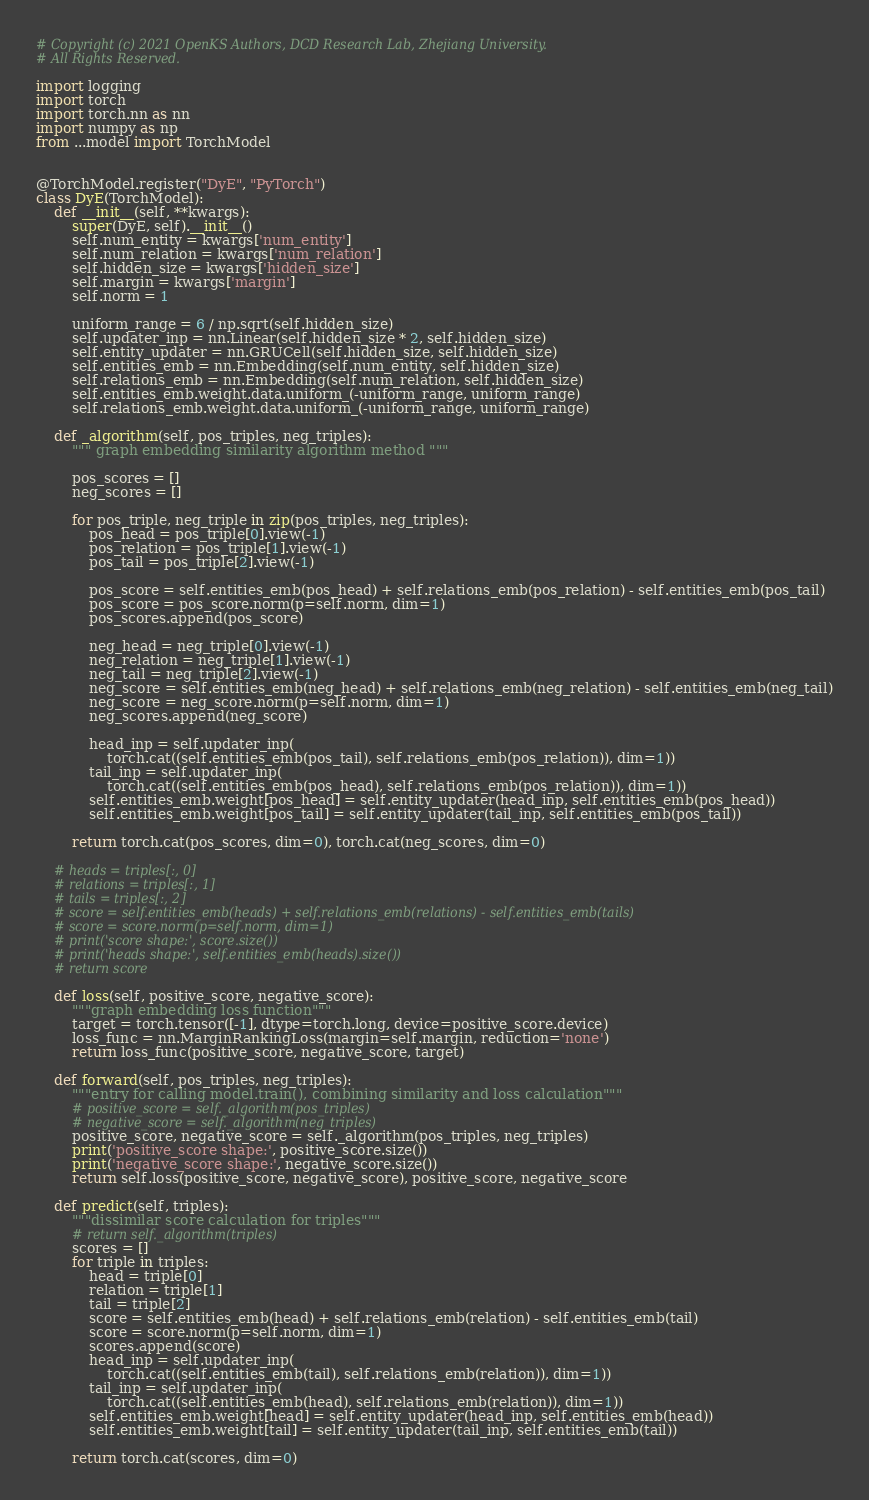Convert code to text. <code><loc_0><loc_0><loc_500><loc_500><_Python_># Copyright (c) 2021 OpenKS Authors, DCD Research Lab, Zhejiang University.
# All Rights Reserved.

import logging
import torch
import torch.nn as nn
import numpy as np
from ...model import TorchModel


@TorchModel.register("DyE", "PyTorch")
class DyE(TorchModel):
    def __init__(self, **kwargs):
        super(DyE, self).__init__()
        self.num_entity = kwargs['num_entity']
        self.num_relation = kwargs['num_relation']
        self.hidden_size = kwargs['hidden_size']
        self.margin = kwargs['margin']
        self.norm = 1

        uniform_range = 6 / np.sqrt(self.hidden_size)
        self.updater_inp = nn.Linear(self.hidden_size * 2, self.hidden_size)
        self.entity_updater = nn.GRUCell(self.hidden_size, self.hidden_size)
        self.entities_emb = nn.Embedding(self.num_entity, self.hidden_size)
        self.relations_emb = nn.Embedding(self.num_relation, self.hidden_size)
        self.entities_emb.weight.data.uniform_(-uniform_range, uniform_range)
        self.relations_emb.weight.data.uniform_(-uniform_range, uniform_range)

    def _algorithm(self, pos_triples, neg_triples):
        """ graph embedding similarity algorithm method """

        pos_scores = []
        neg_scores = []

        for pos_triple, neg_triple in zip(pos_triples, neg_triples):
            pos_head = pos_triple[0].view(-1)
            pos_relation = pos_triple[1].view(-1)
            pos_tail = pos_triple[2].view(-1)

            pos_score = self.entities_emb(pos_head) + self.relations_emb(pos_relation) - self.entities_emb(pos_tail)
            pos_score = pos_score.norm(p=self.norm, dim=1)
            pos_scores.append(pos_score)

            neg_head = neg_triple[0].view(-1)
            neg_relation = neg_triple[1].view(-1)
            neg_tail = neg_triple[2].view(-1)
            neg_score = self.entities_emb(neg_head) + self.relations_emb(neg_relation) - self.entities_emb(neg_tail)
            neg_score = neg_score.norm(p=self.norm, dim=1)
            neg_scores.append(neg_score)

            head_inp = self.updater_inp(
                torch.cat((self.entities_emb(pos_tail), self.relations_emb(pos_relation)), dim=1))
            tail_inp = self.updater_inp(
                torch.cat((self.entities_emb(pos_head), self.relations_emb(pos_relation)), dim=1))
            self.entities_emb.weight[pos_head] = self.entity_updater(head_inp, self.entities_emb(pos_head))
            self.entities_emb.weight[pos_tail] = self.entity_updater(tail_inp, self.entities_emb(pos_tail))

        return torch.cat(pos_scores, dim=0), torch.cat(neg_scores, dim=0)

    # heads = triples[:, 0]
    # relations = triples[:, 1]
    # tails = triples[:, 2]
    # score = self.entities_emb(heads) + self.relations_emb(relations) - self.entities_emb(tails)
    # score = score.norm(p=self.norm, dim=1)
    # print('score shape:', score.size())
    # print('heads shape:', self.entities_emb(heads).size())
    # return score

    def loss(self, positive_score, negative_score):
        """graph embedding loss function"""
        target = torch.tensor([-1], dtype=torch.long, device=positive_score.device)
        loss_func = nn.MarginRankingLoss(margin=self.margin, reduction='none')
        return loss_func(positive_score, negative_score, target)

    def forward(self, pos_triples, neg_triples):
        """entry for calling model.train(), combining similarity and loss calculation"""
        # positive_score = self._algorithm(pos_triples)
        # negative_score = self._algorithm(neg_triples)
        positive_score, negative_score = self._algorithm(pos_triples, neg_triples)
        print('positive_score shape:', positive_score.size())
        print('negative_score shape:', negative_score.size())
        return self.loss(positive_score, negative_score), positive_score, negative_score

    def predict(self, triples):
        """dissimilar score calculation for triples"""
        # return self._algorithm(triples)
        scores = []
        for triple in triples:
            head = triple[0]
            relation = triple[1]
            tail = triple[2]
            score = self.entities_emb(head) + self.relations_emb(relation) - self.entities_emb(tail)
            score = score.norm(p=self.norm, dim=1)
            scores.append(score)
            head_inp = self.updater_inp(
                torch.cat((self.entities_emb(tail), self.relations_emb(relation)), dim=1))
            tail_inp = self.updater_inp(
                torch.cat((self.entities_emb(head), self.relations_emb(relation)), dim=1))
            self.entities_emb.weight[head] = self.entity_updater(head_inp, self.entities_emb(head))
            self.entities_emb.weight[tail] = self.entity_updater(tail_inp, self.entities_emb(tail))

        return torch.cat(scores, dim=0)
</code> 